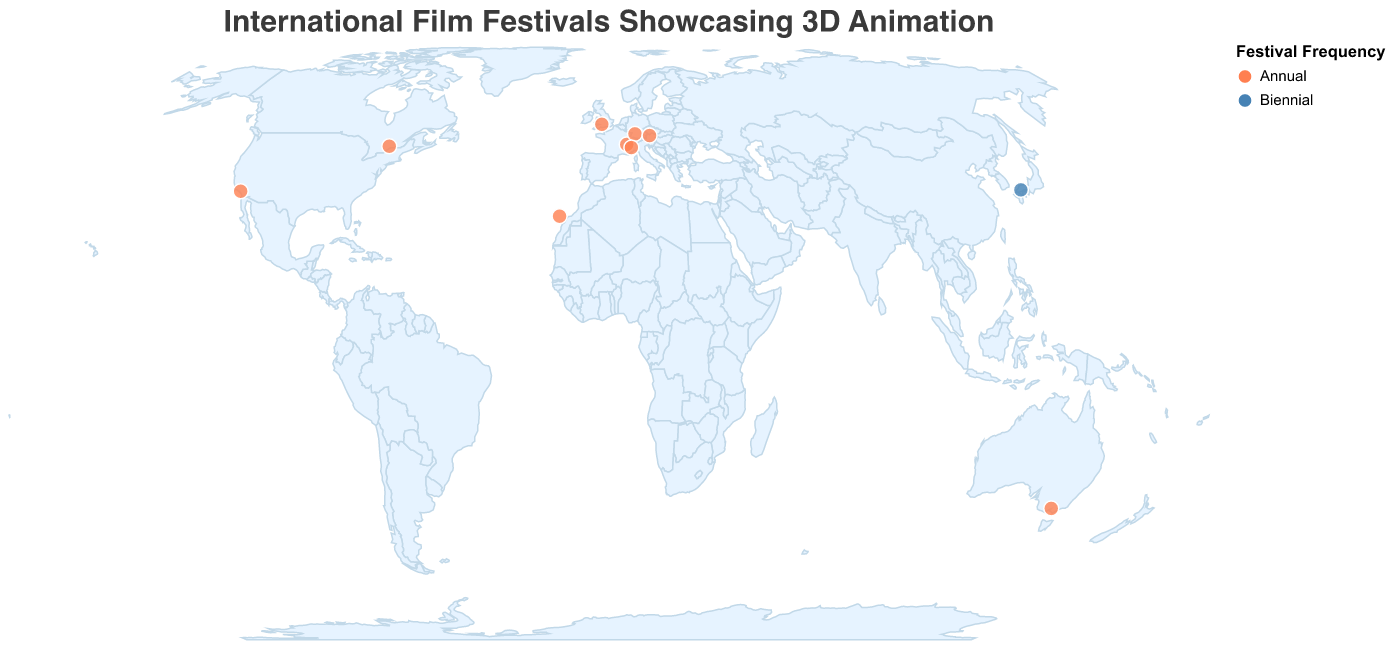What is the title of the plot? The title of a plot is usually prominently displayed at the top of the figure in a larger and bolder font compared to other text elements.
Answer: International Film Festivals Showcasing 3D Animation Which film festival is held in Las Palmas? The tooltip provided by hovering over the circle representing Las Palmas reveals specific data about the film festival held in that location.
Answer: Animayo How are annual and biennial festivals differentiated visually on the plot? The plot uses different colors to distinguish annual festivals from biennial ones. Specifically, annual festivals are marked in one color and biennial ones in another.
Answer: By color What is the primary focus of the festival held in Linz? The tooltip provides information on the focus of each festival when hovering over the location. For Linz, it reveals the focus of the festival held there.
Answer: Digital Arts and Technology How many film festivals are depicted on the plot? Each circle on the plot represents a film festival; by counting these circles, we can determine the total number of festivals.
Answer: 10 Which two festivals are located in the most northern latitudes? By observing the geographic positions on the map, we can identify which festivals are positioned at the highest latitudes.
Answer: Encounters Film Festival (Bristol) and Ottawa International Animation Festival (Ottawa) Is there a festival that focuses on experimental animation? If so, where is it held? The tooltip reveals details about each festival's focus. Identifying the focus on experimental animation and matching it with the location provides the answer.
Answer: Yes, Melbourne Which festival occurs biennially, and where is it located? Among the data points, only one festival has a "Biennial" frequency, which can be identified from both the color and tooltip details.
Answer: Hiroshima International Animation Festival, Hiroshima What are the coordinates of the festival with a focus on 3D animation techniques? By hovering over the Las Palmas location where the Animayo festival is held, the displayed tooltip reveals both the festival focus and its geographic coordinates.
Answer: 28.124169, -15.430504 Compare the focus of festivals held in Stuttgart and Turin. The tooltip details for the markers in Stuttgart and Turin provide the focuses of their respective festivals. Analyzing these details allows for a comparison.
Answer: Stuttgart focuses on Visual Effects and Animation, while Turin focuses on Computer Graphics and Interactive Techniques 